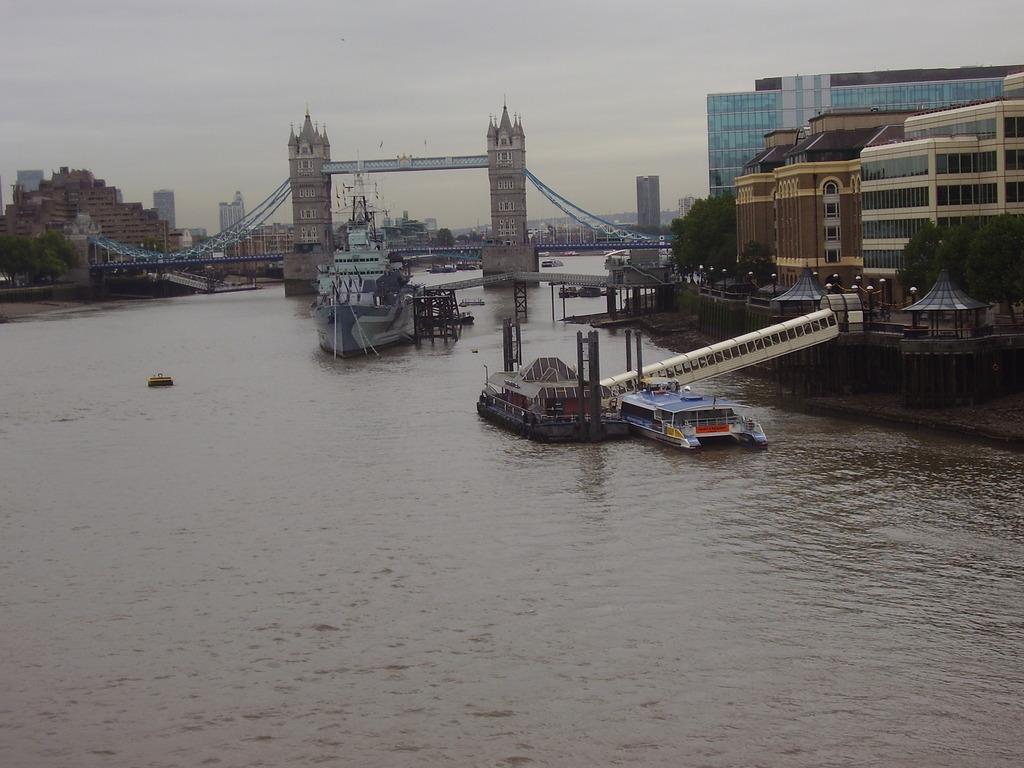Could you give a brief overview of what you see in this image? In this image we can see lake and bridge. Ships are there on the surface of water. Right side of the image buildings and trees are there. Background of the image buildings are present. The sky is in white color. 